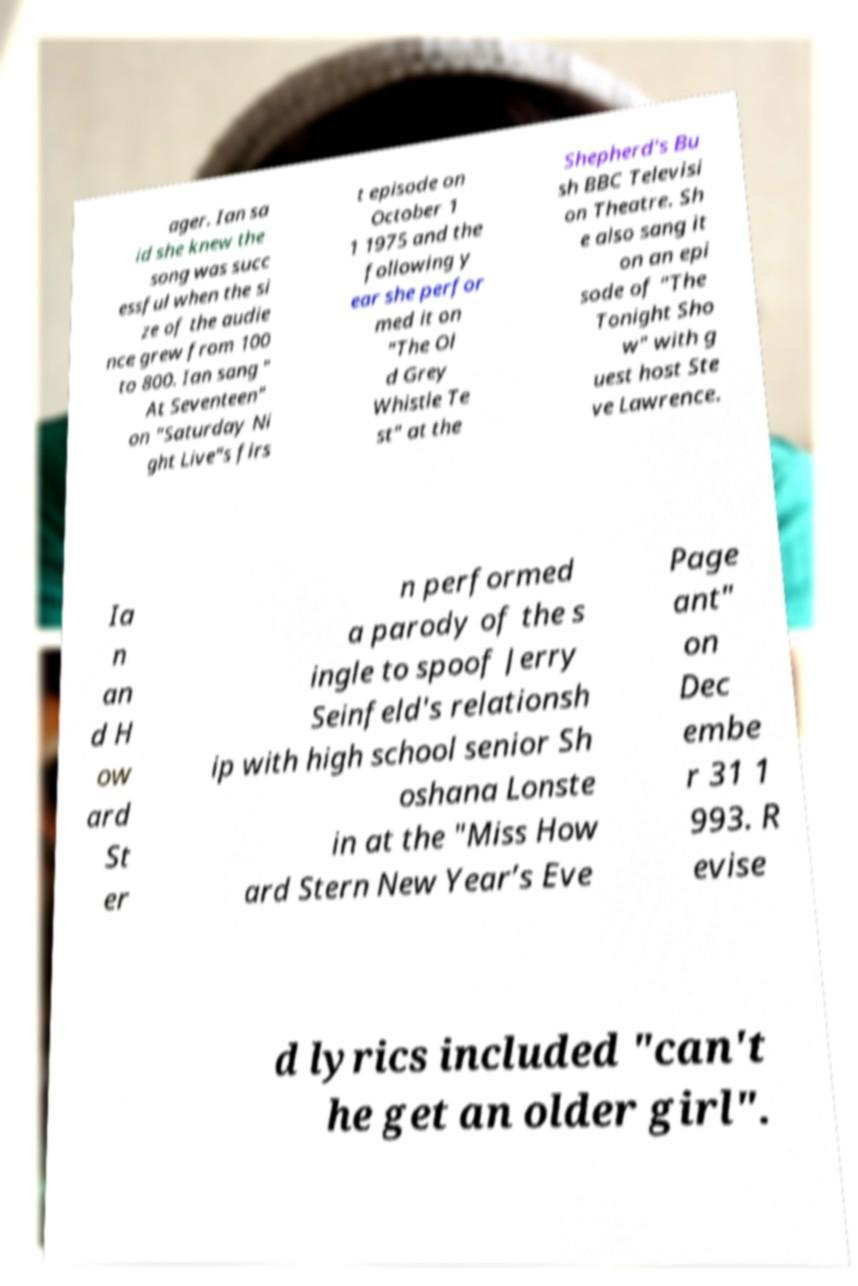Could you assist in decoding the text presented in this image and type it out clearly? ager. Ian sa id she knew the song was succ essful when the si ze of the audie nce grew from 100 to 800. Ian sang " At Seventeen" on "Saturday Ni ght Live"s firs t episode on October 1 1 1975 and the following y ear she perfor med it on "The Ol d Grey Whistle Te st" at the Shepherd's Bu sh BBC Televisi on Theatre. Sh e also sang it on an epi sode of "The Tonight Sho w" with g uest host Ste ve Lawrence. Ia n an d H ow ard St er n performed a parody of the s ingle to spoof Jerry Seinfeld's relationsh ip with high school senior Sh oshana Lonste in at the "Miss How ard Stern New Year’s Eve Page ant" on Dec embe r 31 1 993. R evise d lyrics included "can't he get an older girl". 